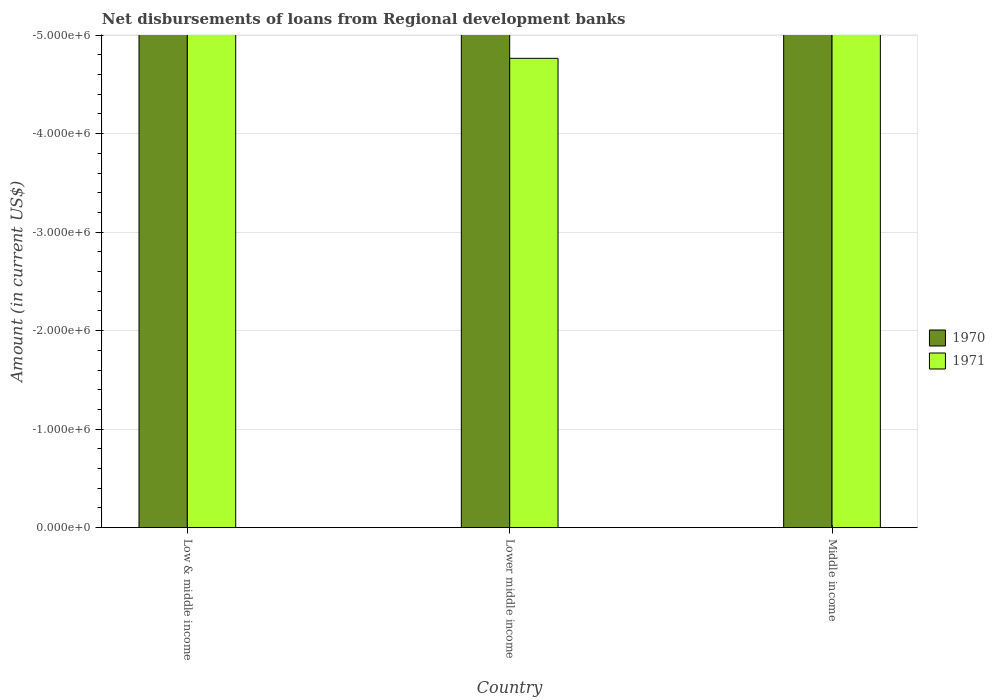How many different coloured bars are there?
Give a very brief answer. 0. Are the number of bars per tick equal to the number of legend labels?
Offer a terse response. No. Are the number of bars on each tick of the X-axis equal?
Offer a very short reply. Yes. What is the label of the 1st group of bars from the left?
Your response must be concise. Low & middle income. In how many cases, is the number of bars for a given country not equal to the number of legend labels?
Your answer should be compact. 3. What is the amount of disbursements of loans from regional development banks in 1970 in Low & middle income?
Provide a succinct answer. 0. What is the difference between the amount of disbursements of loans from regional development banks in 1970 in Middle income and the amount of disbursements of loans from regional development banks in 1971 in Low & middle income?
Offer a very short reply. 0. Are all the bars in the graph horizontal?
Provide a succinct answer. No. How many countries are there in the graph?
Provide a succinct answer. 3. What is the difference between two consecutive major ticks on the Y-axis?
Offer a terse response. 1.00e+06. Are the values on the major ticks of Y-axis written in scientific E-notation?
Your answer should be very brief. Yes. Does the graph contain any zero values?
Your answer should be compact. Yes. Does the graph contain grids?
Ensure brevity in your answer.  Yes. How many legend labels are there?
Your answer should be compact. 2. How are the legend labels stacked?
Keep it short and to the point. Vertical. What is the title of the graph?
Ensure brevity in your answer.  Net disbursements of loans from Regional development banks. Does "2015" appear as one of the legend labels in the graph?
Keep it short and to the point. No. What is the label or title of the X-axis?
Your response must be concise. Country. What is the label or title of the Y-axis?
Offer a terse response. Amount (in current US$). What is the Amount (in current US$) in 1970 in Low & middle income?
Offer a very short reply. 0. What is the Amount (in current US$) in 1970 in Lower middle income?
Your response must be concise. 0. What is the Amount (in current US$) of 1971 in Middle income?
Keep it short and to the point. 0. What is the total Amount (in current US$) in 1970 in the graph?
Ensure brevity in your answer.  0. 